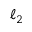Convert formula to latex. <formula><loc_0><loc_0><loc_500><loc_500>\ell _ { 2 }</formula> 